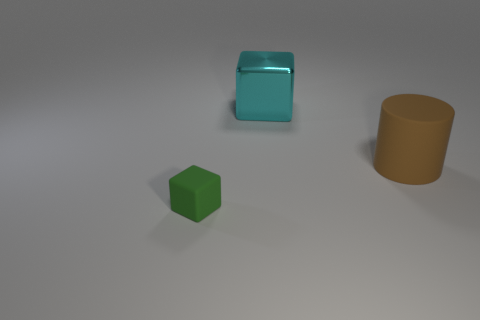What shape is the cyan metal thing that is the same size as the brown cylinder?
Provide a short and direct response. Cube. How many things are either things behind the brown cylinder or matte things on the left side of the cyan shiny cube?
Ensure brevity in your answer.  2. Are there fewer brown matte cylinders than big red balls?
Your answer should be very brief. No. What is the material of the thing that is the same size as the cyan shiny block?
Keep it short and to the point. Rubber. Do the matte object behind the small object and the cube in front of the cylinder have the same size?
Make the answer very short. No. Are there any cylinders made of the same material as the cyan block?
Make the answer very short. No. How many objects are either cubes that are right of the green object or spheres?
Ensure brevity in your answer.  1. Is the object to the right of the cyan metal object made of the same material as the large block?
Your answer should be very brief. No. Is the cyan metal object the same shape as the tiny thing?
Give a very brief answer. Yes. There is a rubber thing to the left of the big cyan shiny cube; how many rubber things are behind it?
Make the answer very short. 1. 